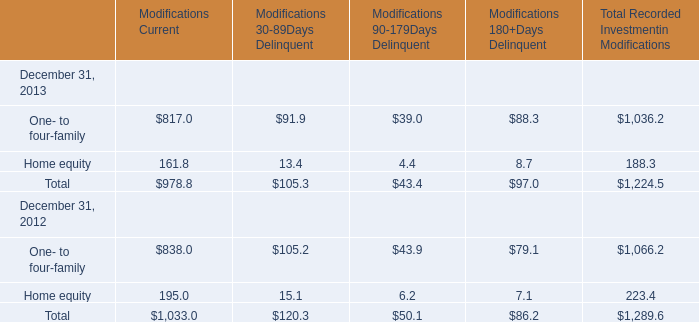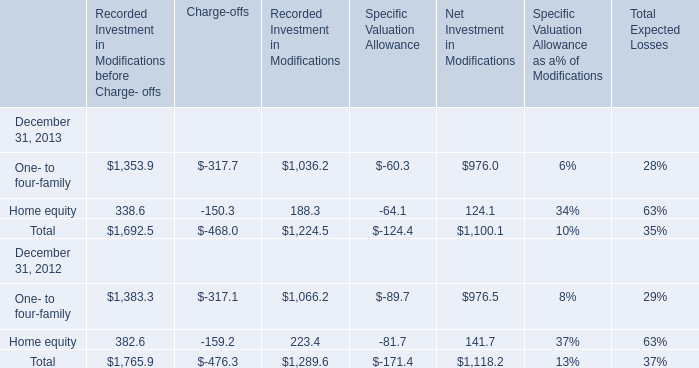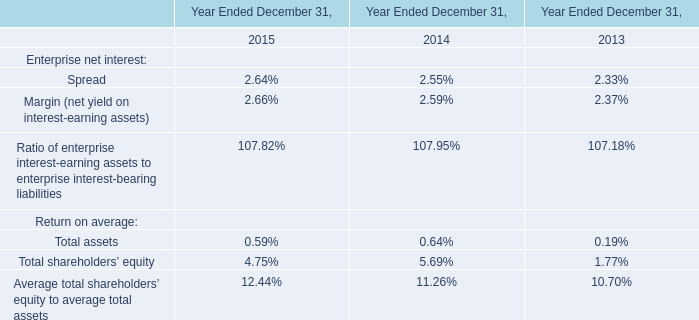What was the total amount of Modifications Current greater than 0 in 2013? 
Computations: (817 + 161.8)
Answer: 978.8. 